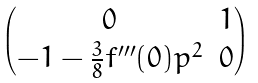Convert formula to latex. <formula><loc_0><loc_0><loc_500><loc_500>\begin{pmatrix} 0 & 1 \\ - 1 - \frac { 3 } { 8 } f ^ { \prime \prime \prime } ( 0 ) p ^ { 2 } & 0 \end{pmatrix}</formula> 